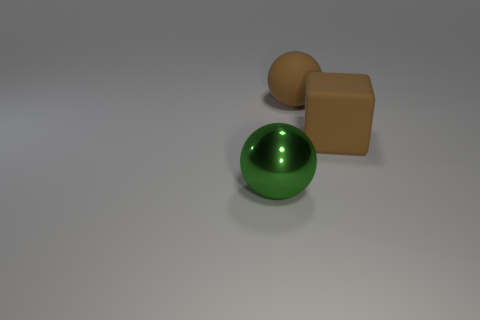Add 1 purple spheres. How many objects exist? 4 Subtract all brown cubes. How many gray spheres are left? 0 Add 3 large brown matte cubes. How many large brown matte cubes exist? 4 Subtract all green spheres. How many spheres are left? 1 Subtract 1 brown blocks. How many objects are left? 2 Subtract all blocks. How many objects are left? 2 Subtract 1 balls. How many balls are left? 1 Subtract all cyan balls. Subtract all gray cylinders. How many balls are left? 2 Subtract all green objects. Subtract all rubber balls. How many objects are left? 1 Add 3 large green metal objects. How many large green metal objects are left? 4 